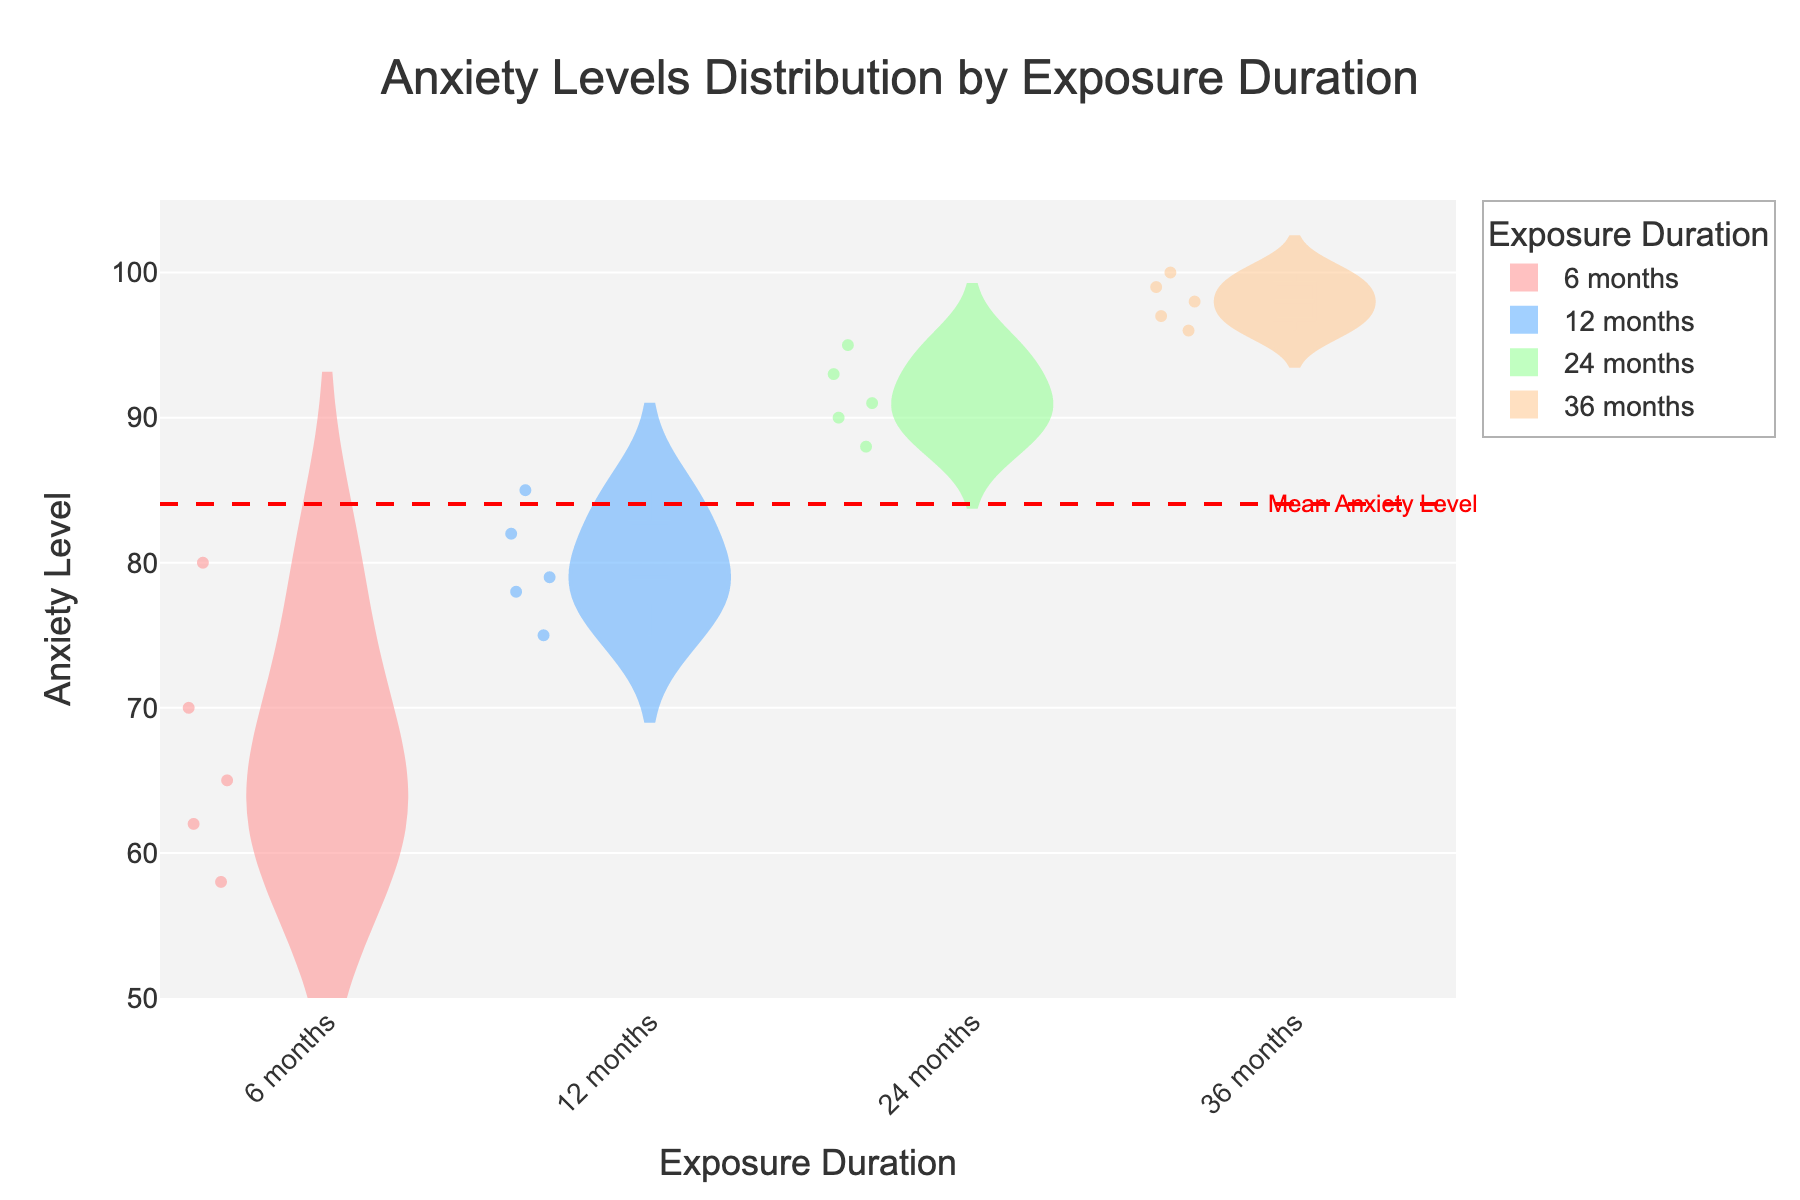What is the title of the figure? The title is typically placed at the top of the figure, written in a larger and bold font to draw attention.
Answer: Anxiety Levels Distribution by Exposure Duration Which exposure duration has the highest anxiety level recorded? By observing all the density plots, look for the highest point reached on the y-axis. The highest point is 100, which is seen in the '36 months' group.
Answer: 36 months What is the mean anxiety level indicated by the red dashed line? The mean anxiety line runs horizontally across the plot, marked by a red dashed line. The annotated text "Mean Anxiety Level" helps identify its location. The y-coordinate for this line can also be cross-referenced with the y-axis tick labels.
Answer: ≈ 83.2 How do anxiety levels for '6 months' compare to '36 months'? Compare the range and density of the anxiety levels in the '6 months' and '36 months' categories. The '36 months' group has a higher concentration at the upper end of the anxiety scale compared to the '6 months' group.
Answer: Higher in '36 months' Which group has the widest spread of anxiety levels? Compare the width of the distributions for each group. The wider the spread of the violin plot, the larger the range of anxiety levels within that group.
Answer: 36 months What is the median anxiety level for the '24 months' duration? The violin plot has a vertical line indicating the median. For the '24 months' group, trace this line to the y-axis to determine the median level.
Answer: Approximately 91 Which exposure duration group appears to have the most consistent anxiety levels? Look at the density and distribution of points for each group. The group with the least spread and most concentrated region represents more consistent levels.
Answer: 12 months Are there outliers present in the '6 months' duration? Outliers are typically shown as individual points outside the main bulk of the distribution. Check for such points in the '6 months' violin plot.
Answer: No outliers Between '12 months' and '24 months', which group has a higher median anxiety level? Identifying the median line within each violin plot, and comparing their positions relative to the y-axis will provide the answer.
Answer: 24 months Does any group have anxiety levels that extend below 60? Observe the lowest points of each violin plot. If any plot dips below the 60 mark on the y-axis, then the answer is yes. However, none of the plots extend below 60.
Answer: No 